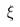<formula> <loc_0><loc_0><loc_500><loc_500>\xi</formula> 